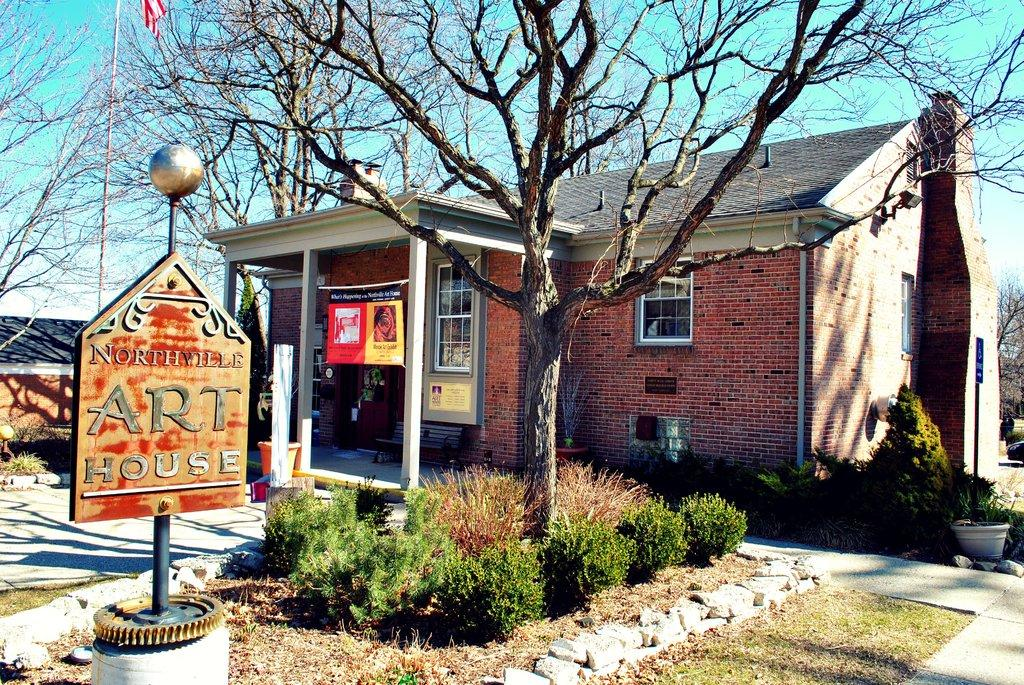What is the main object in the image? There is a board in the image. What is written or displayed on the board? There is text on the board. What can be seen in the background of the image? There are plants, trees, and a house in the background of the image. What type of lace can be seen hanging from the trees in the image? There is no lace present in the image; the trees are not adorned with any lace. 